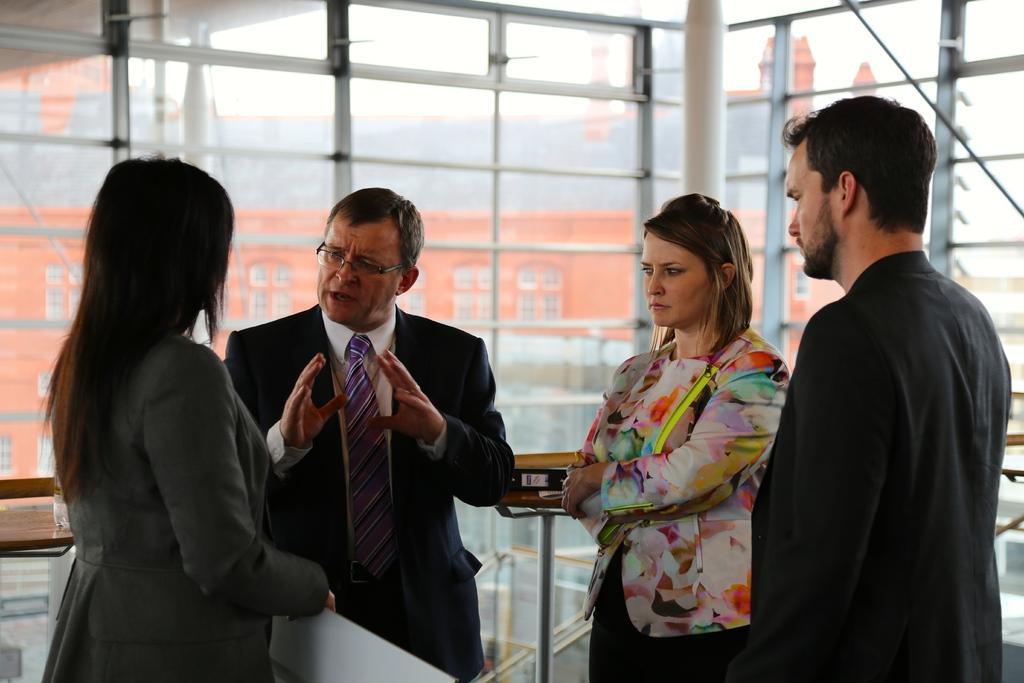Please provide a concise description of this image. In this picture there is a man who is wearing suit, shirt and spectacle. He is standing near to the woman who is wearing blazer. On the right there is a man who is standing near to the women. Back of them we can see tables, file and book. In the background we can see the buildings. At the top there is a sky. 